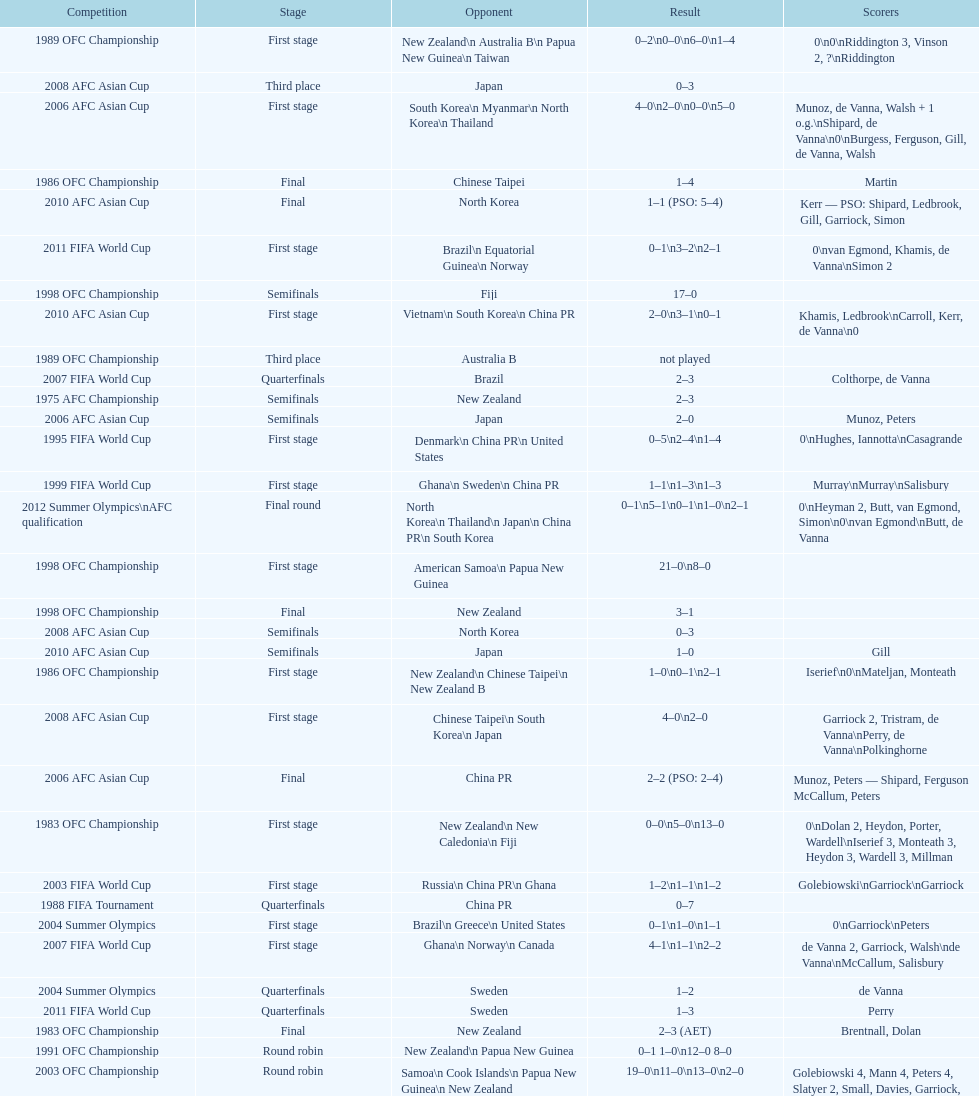What it the total number of countries in the first stage of the 2008 afc asian cup? 4. 